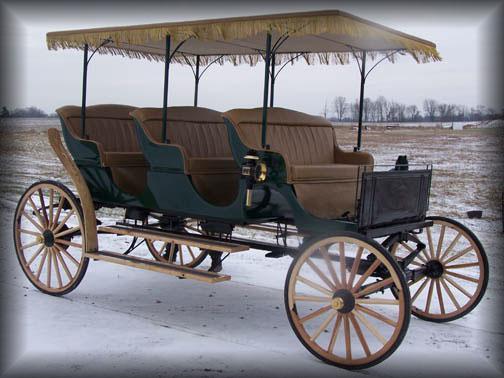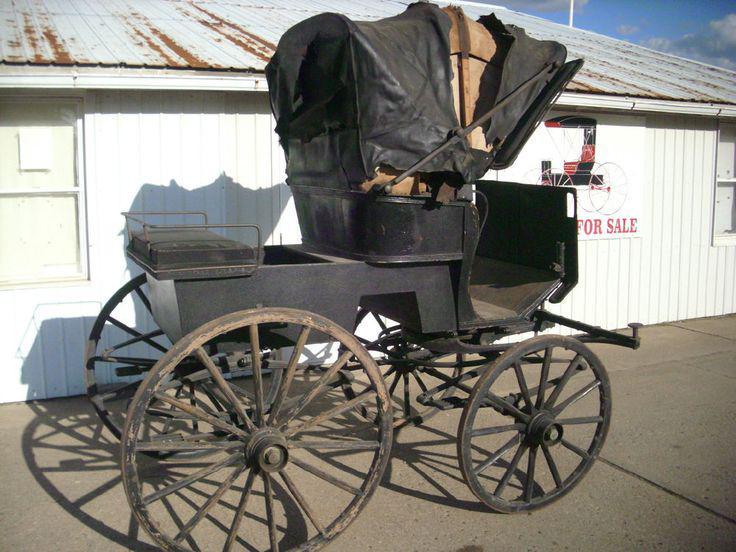The first image is the image on the left, the second image is the image on the right. For the images displayed, is the sentence "Both images are vintage photos of a carriage." factually correct? Answer yes or no. No. 